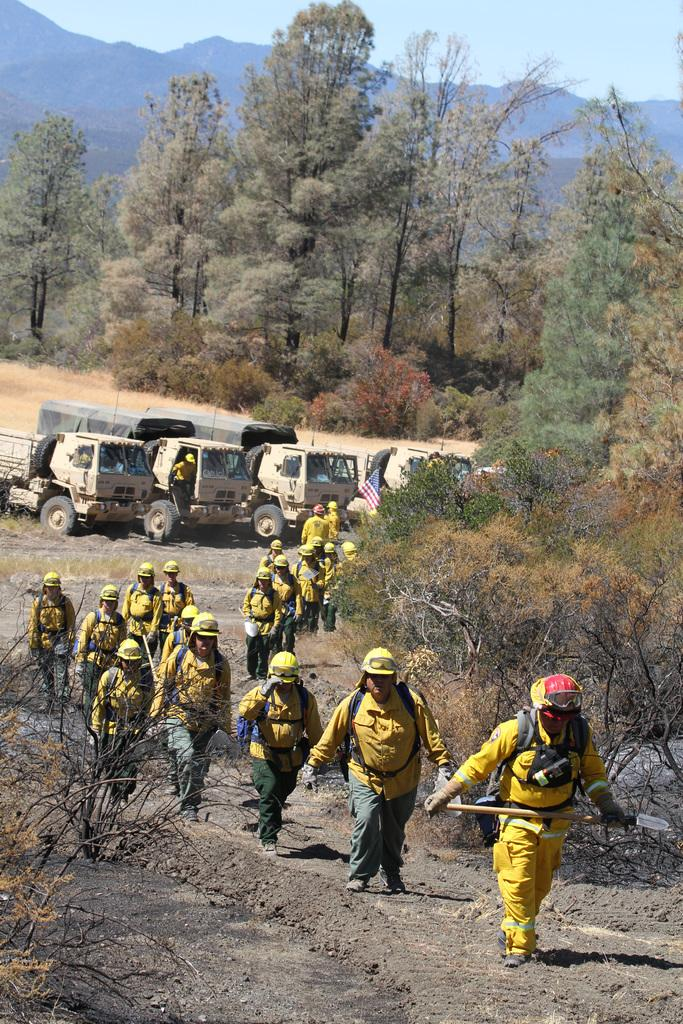What are the people in the image doing? The people in the image are walking. What else can be seen in the image besides people? There are vehicles, sand, trees, and mountains in the background in the image. What is the sky like in the image? The sky is visible in the image. What type of rhythm does the beast in the image have? There is no beast present in the image. Can you tell me the result of adding the number of trees and mountains in the image? The image does not provide numerical information about the number of trees and mountains, so it is not possible to perform the addition. 